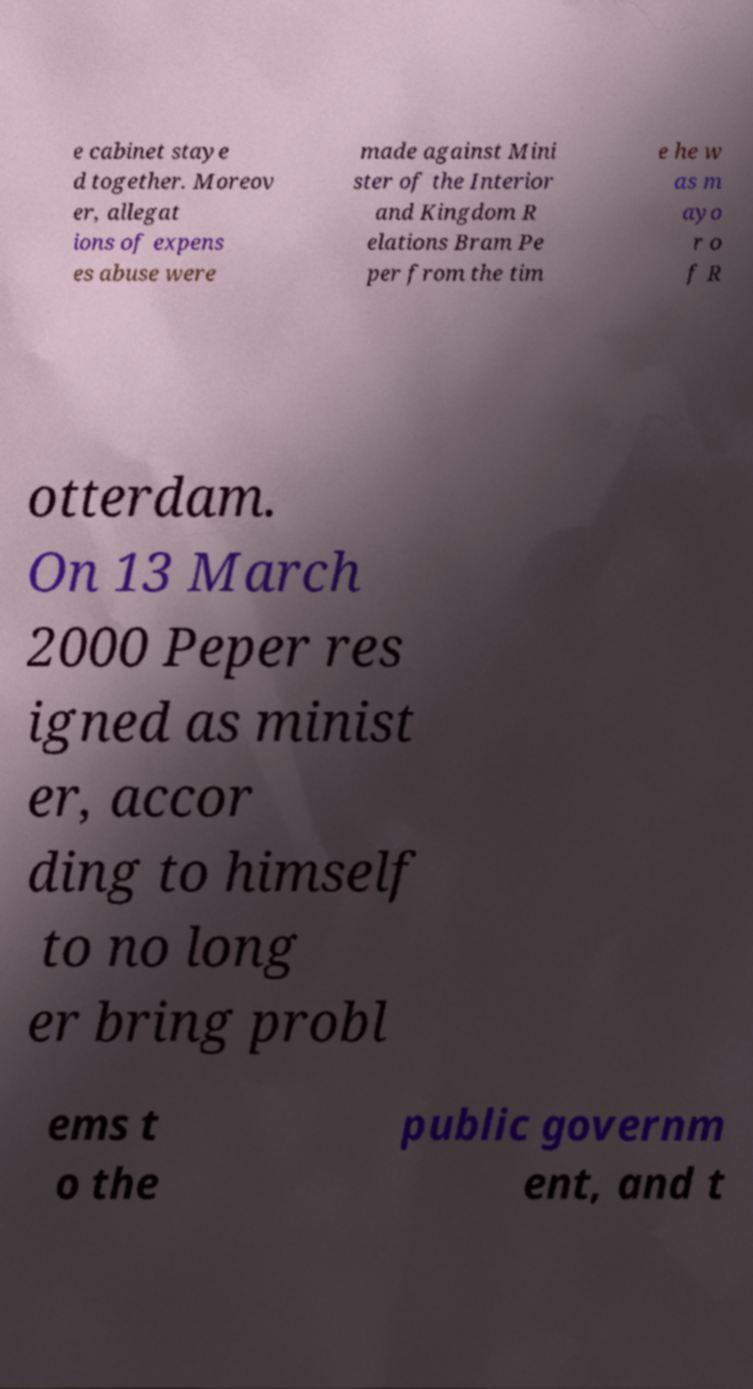Could you extract and type out the text from this image? e cabinet staye d together. Moreov er, allegat ions of expens es abuse were made against Mini ster of the Interior and Kingdom R elations Bram Pe per from the tim e he w as m ayo r o f R otterdam. On 13 March 2000 Peper res igned as minist er, accor ding to himself to no long er bring probl ems t o the public governm ent, and t 